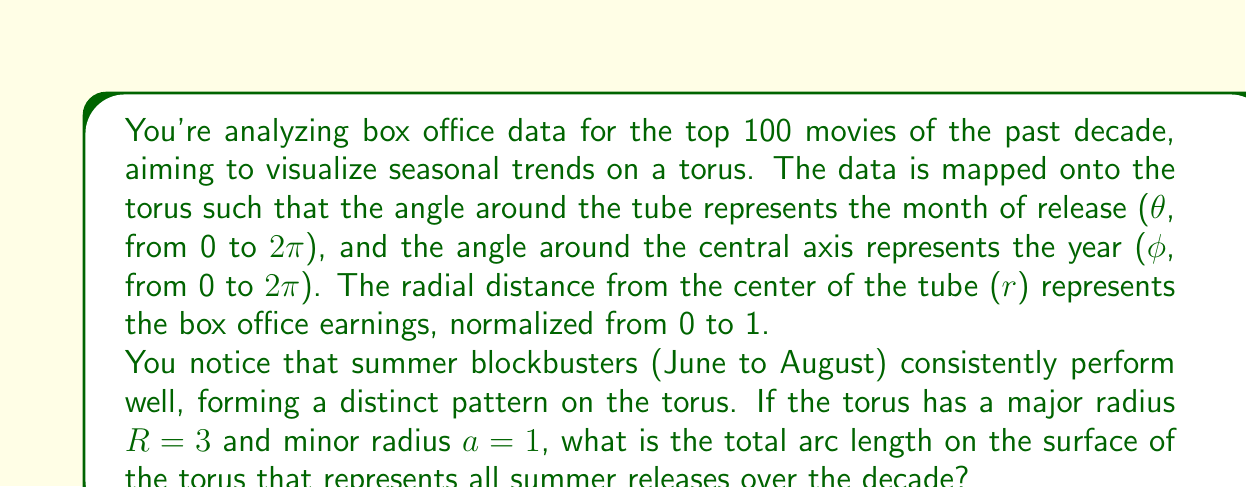Teach me how to tackle this problem. Let's approach this step-by-step:

1) The parametric equations for a torus are:
   $x = (R + a\cos\theta)\cos\phi$
   $y = (R + a\cos\theta)\sin\phi$
   $z = a\sin\theta$

2) The arc length on a torus surface is given by:
   $$s = \int_{\theta_1}^{\theta_2} \sqrt{(R + a\cos\theta)^2 + a^2} d\theta$$

3) Summer months (June to August) span 1/4 of the year, so θ goes from 0 to π/2.

4) We need this for all 10 years, so we'll multiply by 10.

5) Substituting R = 3 and a = 1:
   $$s = 10 \int_{0}^{\pi/2} \sqrt{(3 + \cos\theta)^2 + 1} d\theta$$

6) This integral doesn't have a simple closed form. We can evaluate it numerically:
   $$s \approx 10 * 3.8797 = 38.797$$

The result is in the same units as R and a, which we can assume to be arbitrary units for this visualization.
Answer: The total arc length representing summer releases over the decade is approximately 38.797 units. 